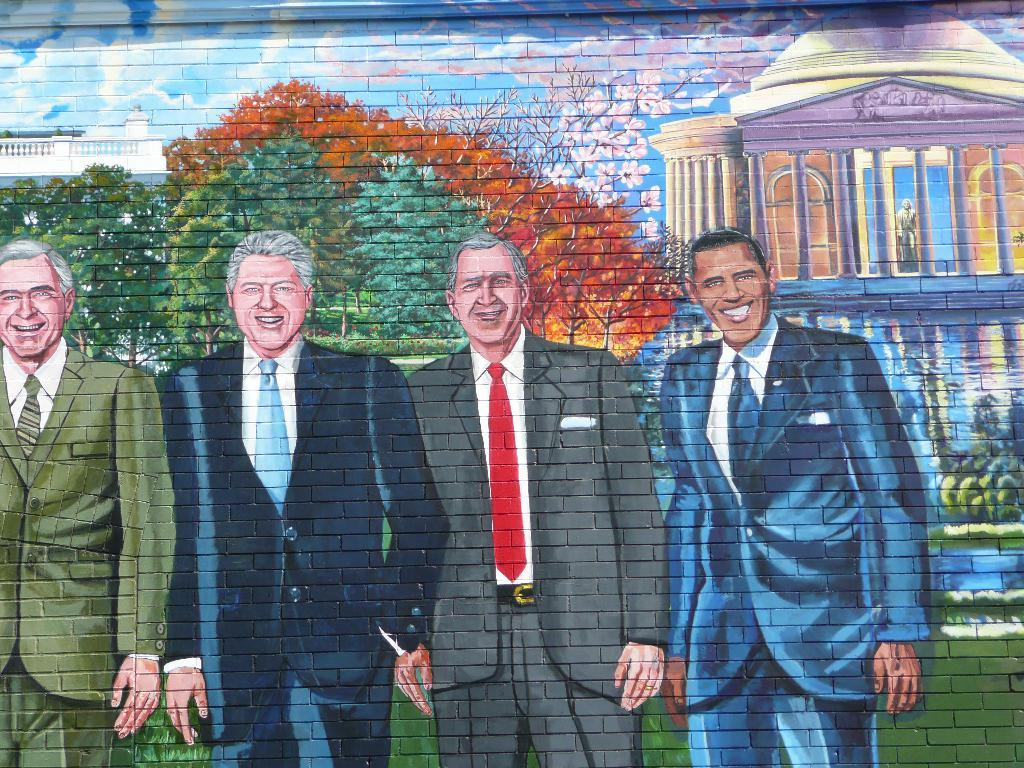What type of structure is depicted in the image? There is a brick wall in the image. What is drawn on the brick wall? A house, persons, and trees are drawn on the brick wall. What type of dress is the apparatus wearing in the image? There is no apparatus or dress present in the image. The image only features a brick wall with drawings of a house, persons, and trees. 